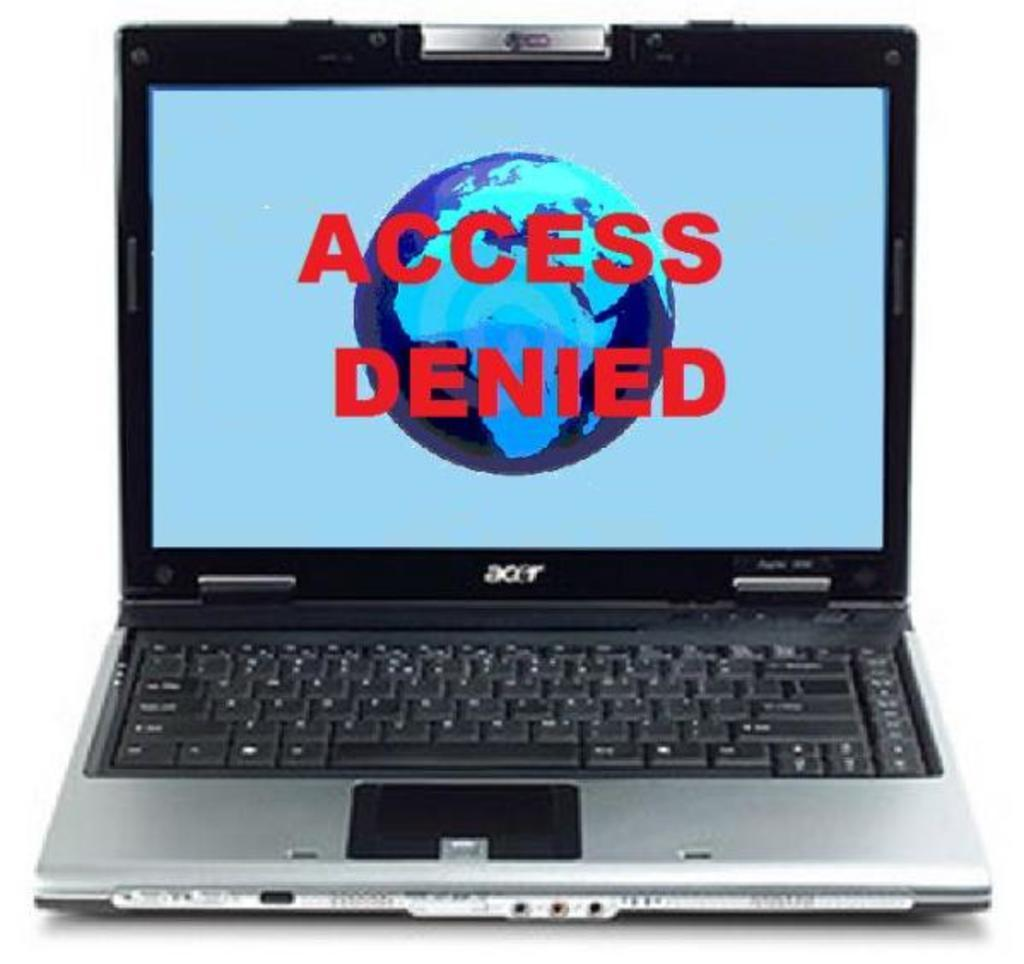<image>
Describe the image concisely. A laptop screen says Access Denied over a picture of the Earth. 